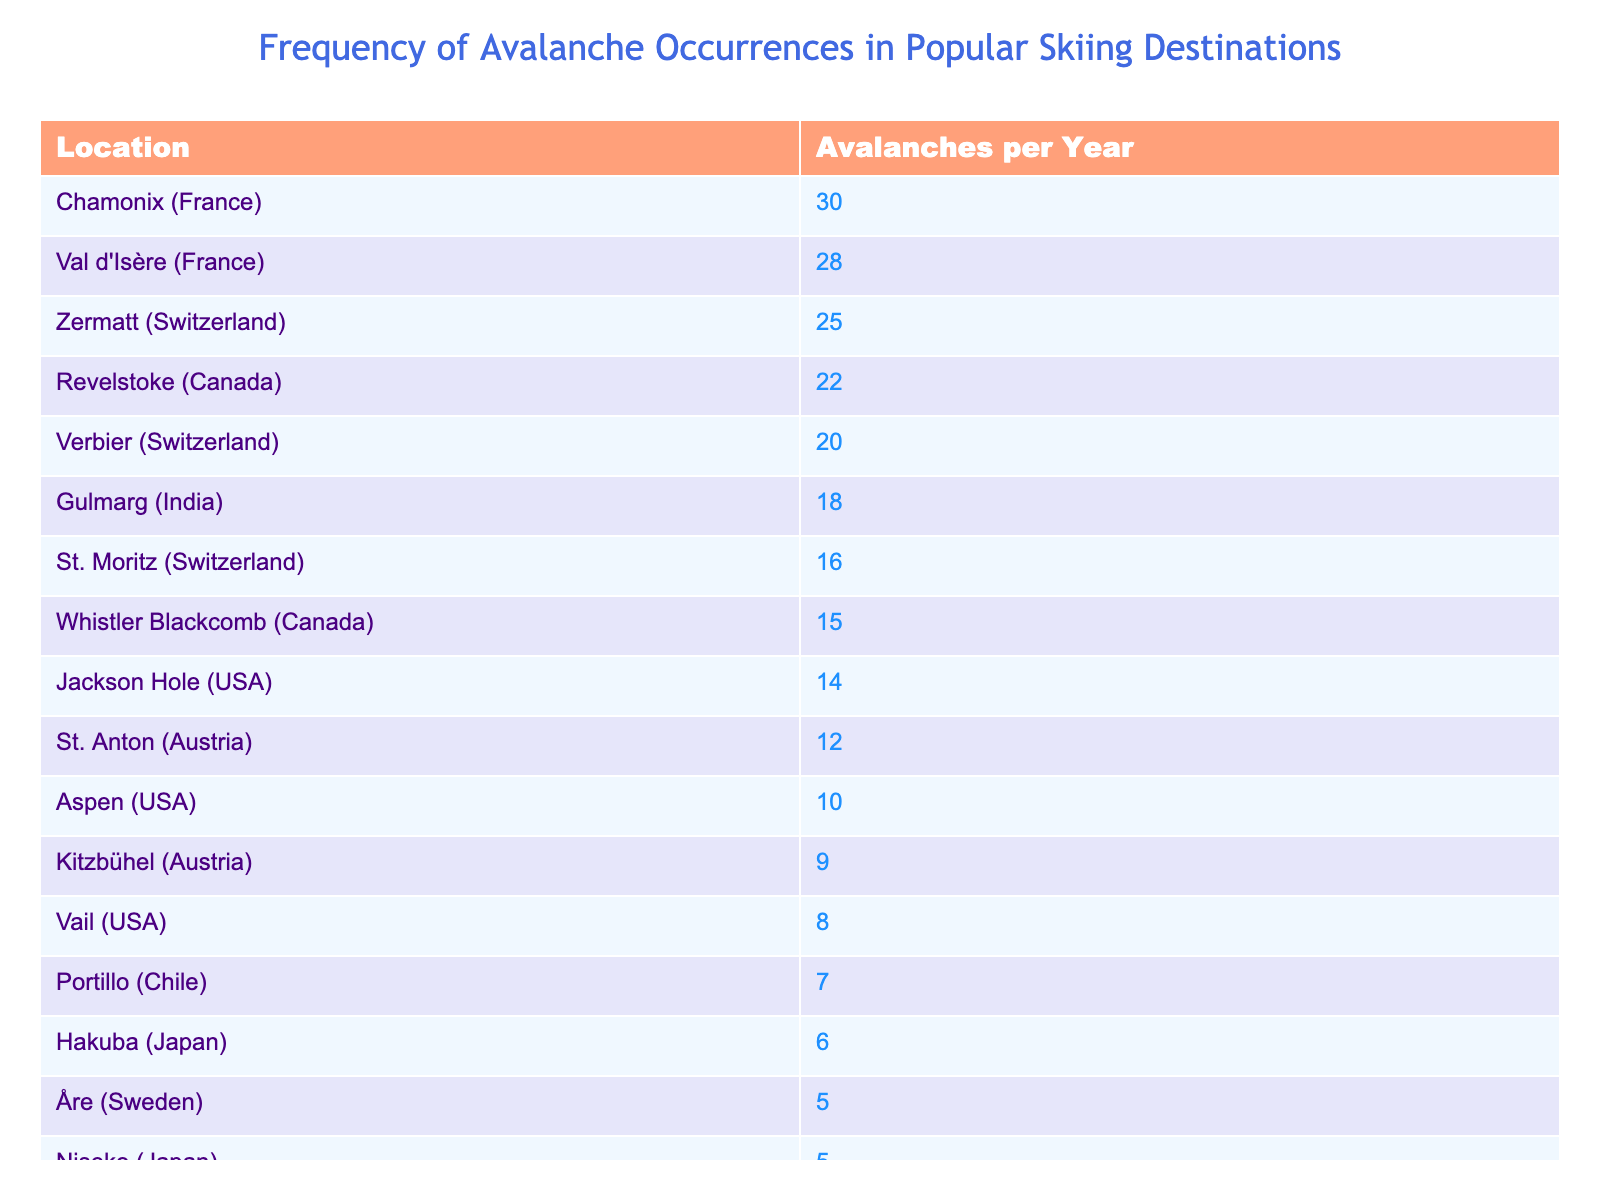What skiing destination has the highest number of avalanches per year? The table shows that Chamonix in France has the highest number of avalanches, with a total of 30 occurrences per year.
Answer: Chamonix (France) How many avalanches does Zermatt experience compared to Vail? Zermatt has 25 avalanches per year, while Vail has 8. The difference is 25 - 8 = 17, meaning Zermatt experiences 17 more avalanches than Vail.
Answer: 17 Is the average number of avalanches in Australia higher than in Japan? The average number of avalanches for Australia (Thredbo = 2) and Japan (Niseko = 5, Hakuba = 6) is (2 + 5 + 6)/3 = 4.33, thus the average in Australia is not higher than in Japan.
Answer: No What is the total number of avalanches for all destinations in Switzerland? Summing the avalanches in Switzerland: Zermatt (25) + Verbier (20) + St. Moritz (16) = 61. Therefore, the total number of avalanches in Switzerland is 61.
Answer: 61 Which country has the most skiing destinations listed in the table? The USA has three skiing destinations (Vail, Aspen, Jackson Hole), and it's the highest count among the countries listed.
Answer: USA What is the difference in avalanche occurrences between the destination with the most and the one with the least? Chamonix has 30 avalanches (most), while Cerro Catedral has 4 (least). The difference is 30 - 4 = 26, so there are 26 more avalanches in Chamonix.
Answer: 26 Are there more destinations with 10 or fewer avalanches compared to those with 15 or more? The destinations with 10 or fewer avalanches are Thredbo (2), Treble Cone (3), Hakuba (6), Cerro Catedral (4), and Niseko (5), totaling 5 destinations. The ones with 15 or more are Chamonix (30), Verbier (20), Zermatt (25), Revelstoke (22), Gulmarg (18), and Val d'Isère (28), totaling 6 destinations. Since 6 > 5, there are more destinations with 15 or more avalanches.
Answer: Yes Which locations have a combined total of exactly 40 avalanches per year? By examining combinations, Jackson Hole (14) and St. Anton (12) add up to 26, and adding Aspen (10) results in 36; however, adding anyone from the lower group doesn't reach 40. Therefore, no combination sums exactly to 40 with distinct locations.
Answer: None 